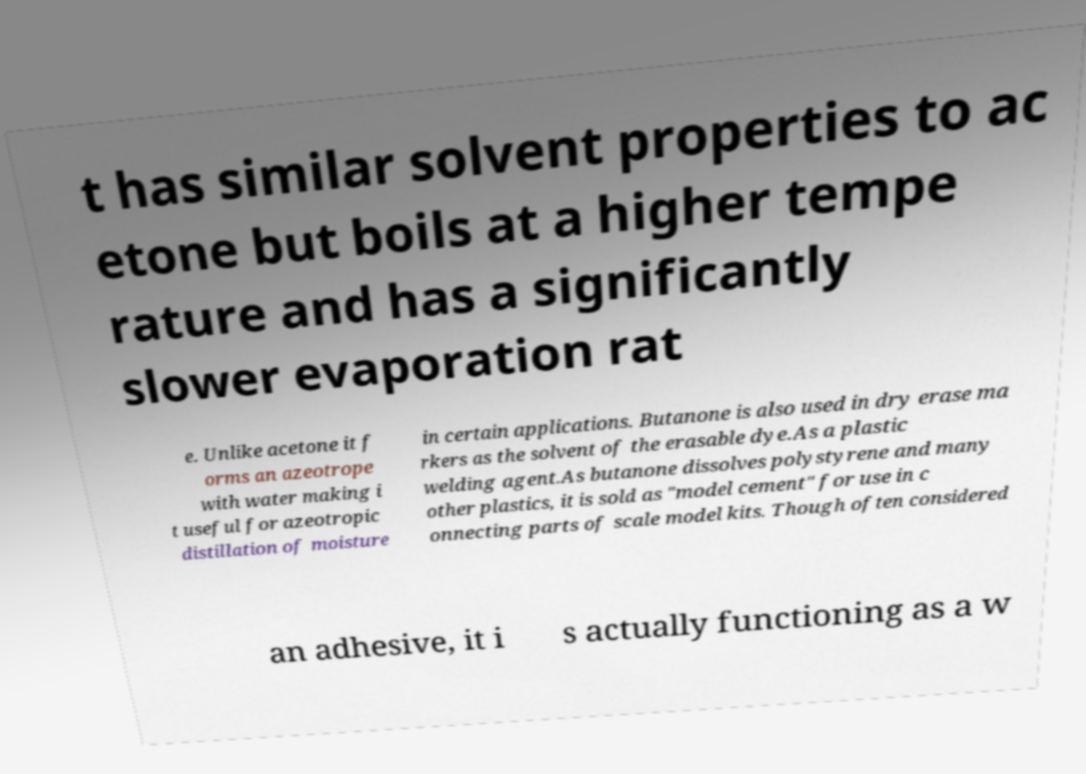What messages or text are displayed in this image? I need them in a readable, typed format. t has similar solvent properties to ac etone but boils at a higher tempe rature and has a significantly slower evaporation rat e. Unlike acetone it f orms an azeotrope with water making i t useful for azeotropic distillation of moisture in certain applications. Butanone is also used in dry erase ma rkers as the solvent of the erasable dye.As a plastic welding agent.As butanone dissolves polystyrene and many other plastics, it is sold as "model cement" for use in c onnecting parts of scale model kits. Though often considered an adhesive, it i s actually functioning as a w 